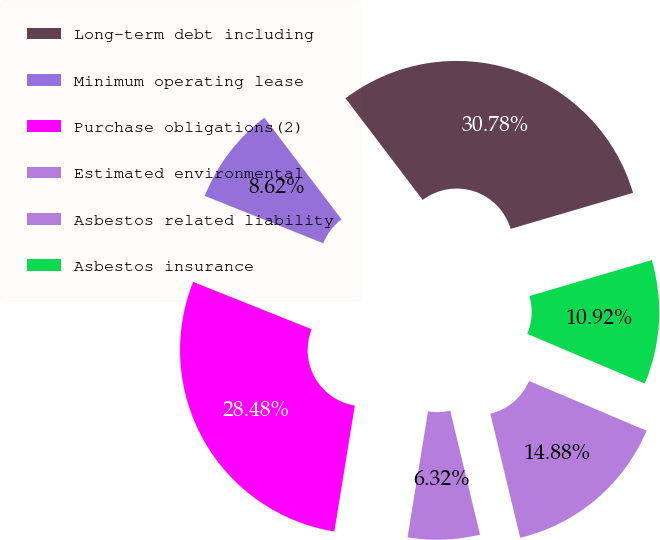Convert chart to OTSL. <chart><loc_0><loc_0><loc_500><loc_500><pie_chart><fcel>Long-term debt including<fcel>Minimum operating lease<fcel>Purchase obligations(2)<fcel>Estimated environmental<fcel>Asbestos related liability<fcel>Asbestos insurance<nl><fcel>30.78%<fcel>8.62%<fcel>28.48%<fcel>6.32%<fcel>14.88%<fcel>10.92%<nl></chart> 